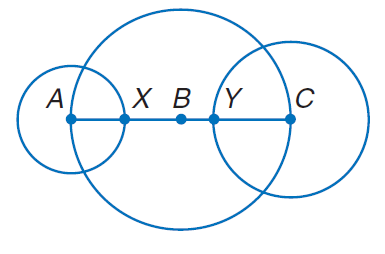Answer the mathemtical geometry problem and directly provide the correct option letter.
Question: The diameters of \odot A, \odot B, and \odot C are 10 inches, 20 inches, and 14 inches, respectively. Find B Y.
Choices: A: 3 B: 6 C: 9 D: 12 A 